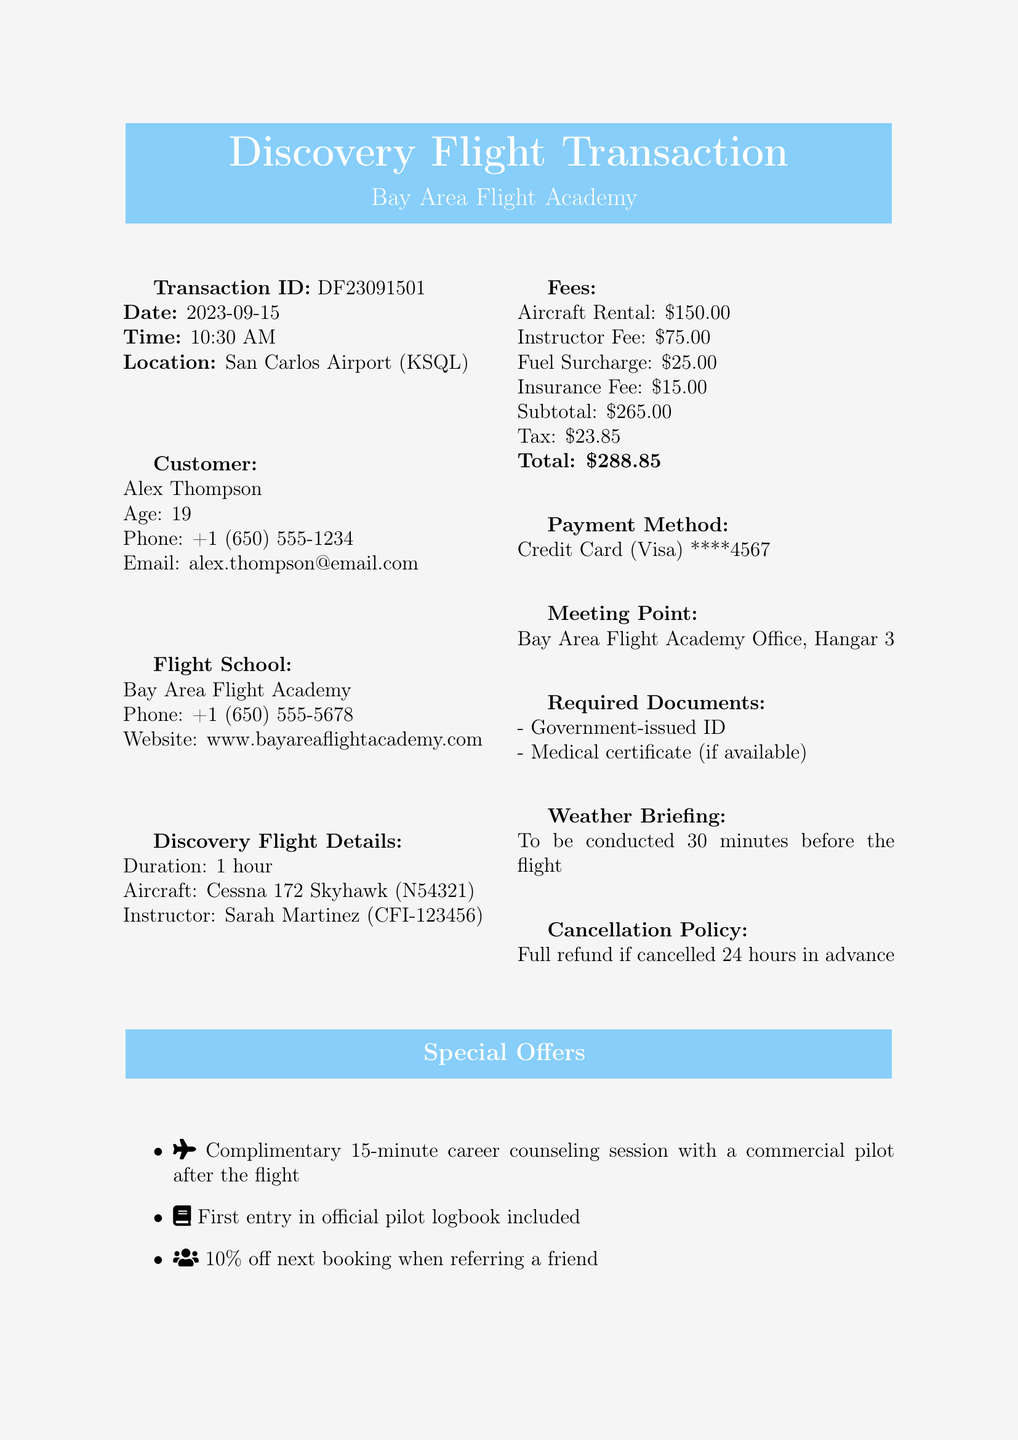What is the transaction ID? The transaction ID is located in the document and identifies this specific booking transaction.
Answer: DF23091501 Who is the instructor for the discovery flight? The instructor's name is mentioned in the document and identifies the person conducting the flight lesson.
Answer: Sarah Martinez What is the aircraft type for the flight? The document specifies the type of aircraft that will be used for the discovery flight.
Answer: Cessna 172 Skyhawk What is the total fee for the discovery flight? The total fee is the final amount that includes all fees and taxes associated with the flight booking.
Answer: $288.85 What is the required age to book the discovery flight? The document provides the age of the customer, which indicates the minimum age for booking.
Answer: 19 How long is the duration of the flight? The document clearly states the duration of the discovery flight in hours.
Answer: 1 hour What is the fuel surcharge amount? The fee details in the document include specific breakdowns, including the fuel surcharge for the flight.
Answer: $25.00 What is the cancellation policy for this booking? The document specifies conditions regarding cancellation and potential refunds for the booking.
Answer: Full refund if cancelled 24 hours in advance What special offer is included with the flight? The special notes section describes a benefit that comes with the flight booking.
Answer: Complimentary 15-minute career counseling session 